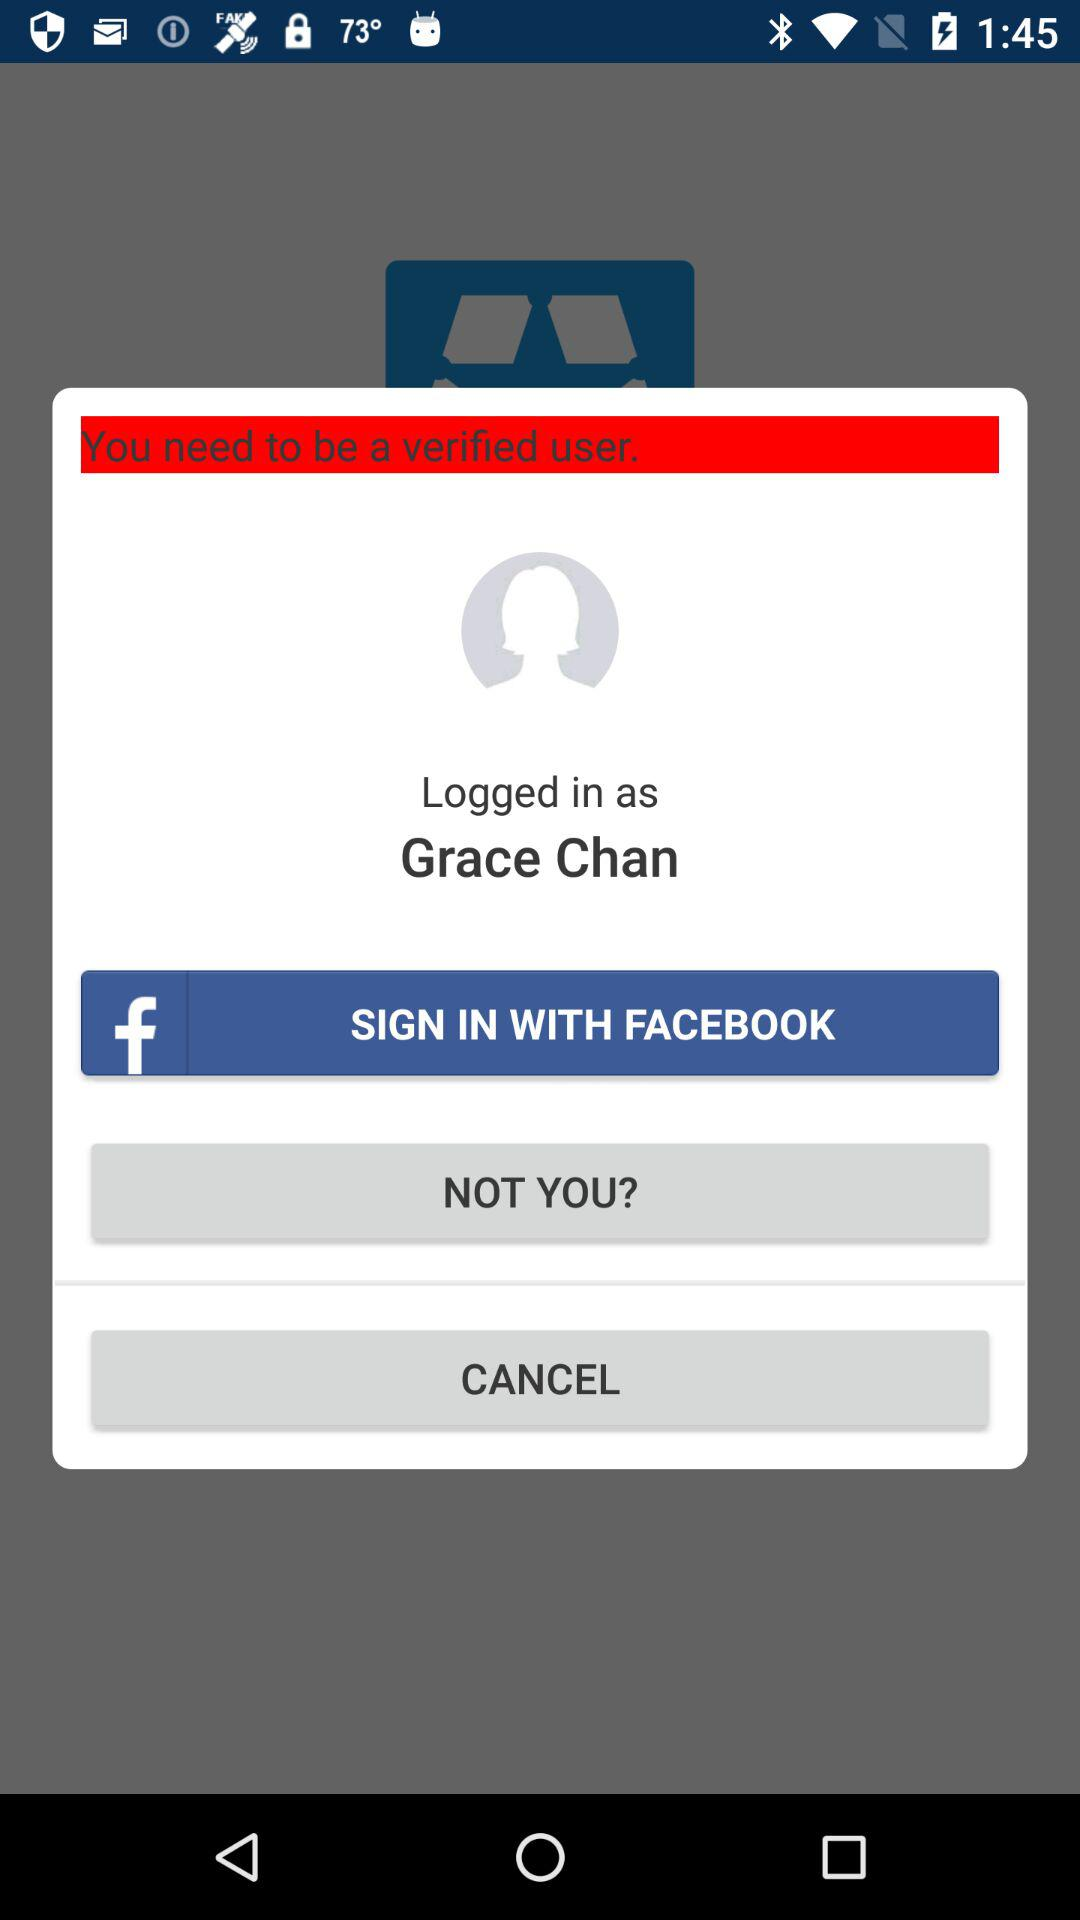How can Grace Chan become a verified user?
When the provided information is insufficient, respond with <no answer>. <no answer> 